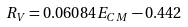Convert formula to latex. <formula><loc_0><loc_0><loc_500><loc_500>R _ { V } = 0 . 0 6 0 8 4 E _ { C M } - 0 . 4 4 2</formula> 